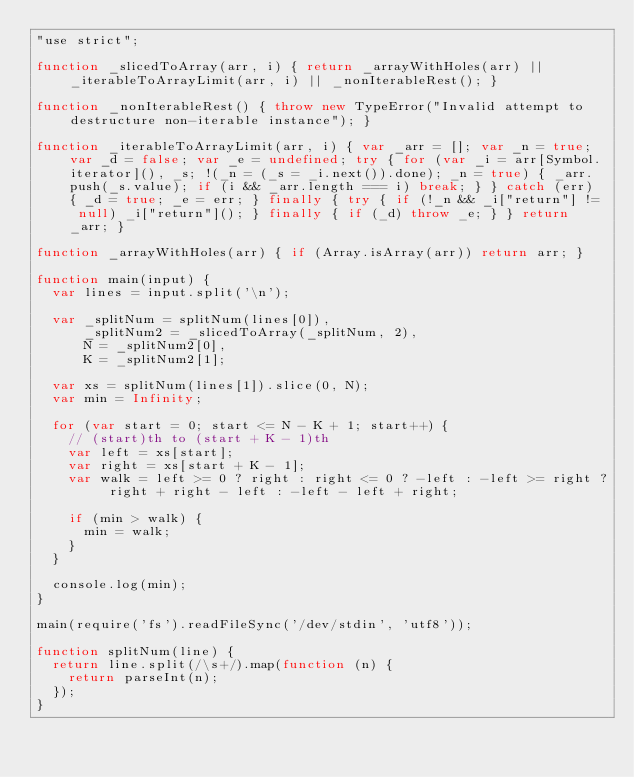Convert code to text. <code><loc_0><loc_0><loc_500><loc_500><_JavaScript_>"use strict";

function _slicedToArray(arr, i) { return _arrayWithHoles(arr) || _iterableToArrayLimit(arr, i) || _nonIterableRest(); }

function _nonIterableRest() { throw new TypeError("Invalid attempt to destructure non-iterable instance"); }

function _iterableToArrayLimit(arr, i) { var _arr = []; var _n = true; var _d = false; var _e = undefined; try { for (var _i = arr[Symbol.iterator](), _s; !(_n = (_s = _i.next()).done); _n = true) { _arr.push(_s.value); if (i && _arr.length === i) break; } } catch (err) { _d = true; _e = err; } finally { try { if (!_n && _i["return"] != null) _i["return"](); } finally { if (_d) throw _e; } } return _arr; }

function _arrayWithHoles(arr) { if (Array.isArray(arr)) return arr; }

function main(input) {
  var lines = input.split('\n');

  var _splitNum = splitNum(lines[0]),
      _splitNum2 = _slicedToArray(_splitNum, 2),
      N = _splitNum2[0],
      K = _splitNum2[1];

  var xs = splitNum(lines[1]).slice(0, N);
  var min = Infinity;

  for (var start = 0; start <= N - K + 1; start++) {
    // (start)th to (start + K - 1)th
    var left = xs[start];
    var right = xs[start + K - 1];
    var walk = left >= 0 ? right : right <= 0 ? -left : -left >= right ? right + right - left : -left - left + right;

    if (min > walk) {
      min = walk;
    }
  }

  console.log(min);
}

main(require('fs').readFileSync('/dev/stdin', 'utf8'));

function splitNum(line) {
  return line.split(/\s+/).map(function (n) {
    return parseInt(n);
  });
}
</code> 